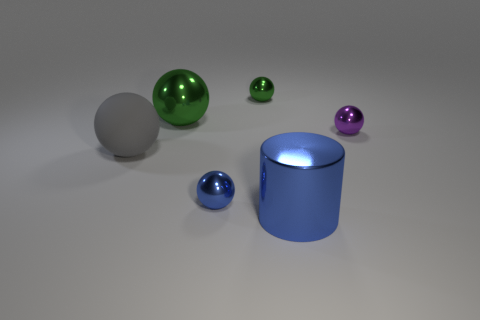What material is the small thing that is the same color as the shiny cylinder?
Ensure brevity in your answer.  Metal. Is there a small metallic sphere that has the same color as the large rubber object?
Offer a terse response. No. There is a big matte thing; is its shape the same as the big shiny thing that is in front of the tiny purple metal thing?
Offer a very short reply. No. Are there any blue cylinders made of the same material as the purple sphere?
Make the answer very short. Yes. Are there any small metallic things behind the tiny thing that is right of the large object that is in front of the blue sphere?
Ensure brevity in your answer.  Yes. What number of other things are the same shape as the tiny purple thing?
Your answer should be compact. 4. There is a big object that is right of the big metal object behind the matte object on the left side of the large blue cylinder; what is its color?
Your answer should be compact. Blue. How many green shiny spheres are there?
Your response must be concise. 2. What number of large things are shiny objects or purple metal balls?
Ensure brevity in your answer.  2. There is a blue metallic thing that is the same size as the gray matte object; what shape is it?
Make the answer very short. Cylinder. 